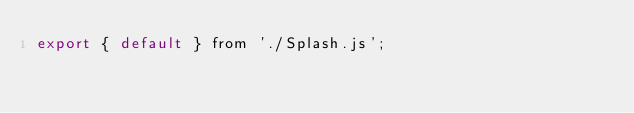<code> <loc_0><loc_0><loc_500><loc_500><_JavaScript_>export { default } from './Splash.js';
</code> 